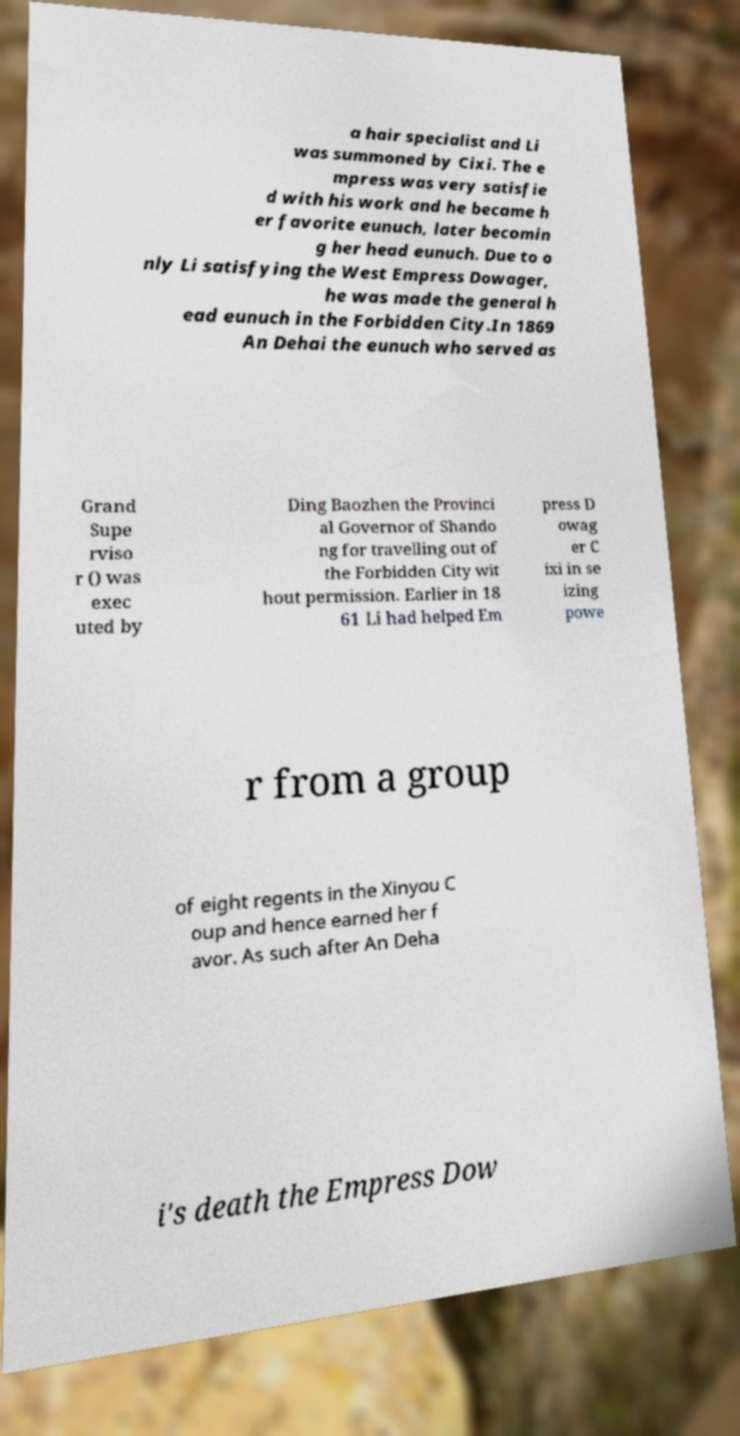Can you read and provide the text displayed in the image?This photo seems to have some interesting text. Can you extract and type it out for me? a hair specialist and Li was summoned by Cixi. The e mpress was very satisfie d with his work and he became h er favorite eunuch, later becomin g her head eunuch. Due to o nly Li satisfying the West Empress Dowager, he was made the general h ead eunuch in the Forbidden City.In 1869 An Dehai the eunuch who served as Grand Supe rviso r () was exec uted by Ding Baozhen the Provinci al Governor of Shando ng for travelling out of the Forbidden City wit hout permission. Earlier in 18 61 Li had helped Em press D owag er C ixi in se izing powe r from a group of eight regents in the Xinyou C oup and hence earned her f avor. As such after An Deha i's death the Empress Dow 